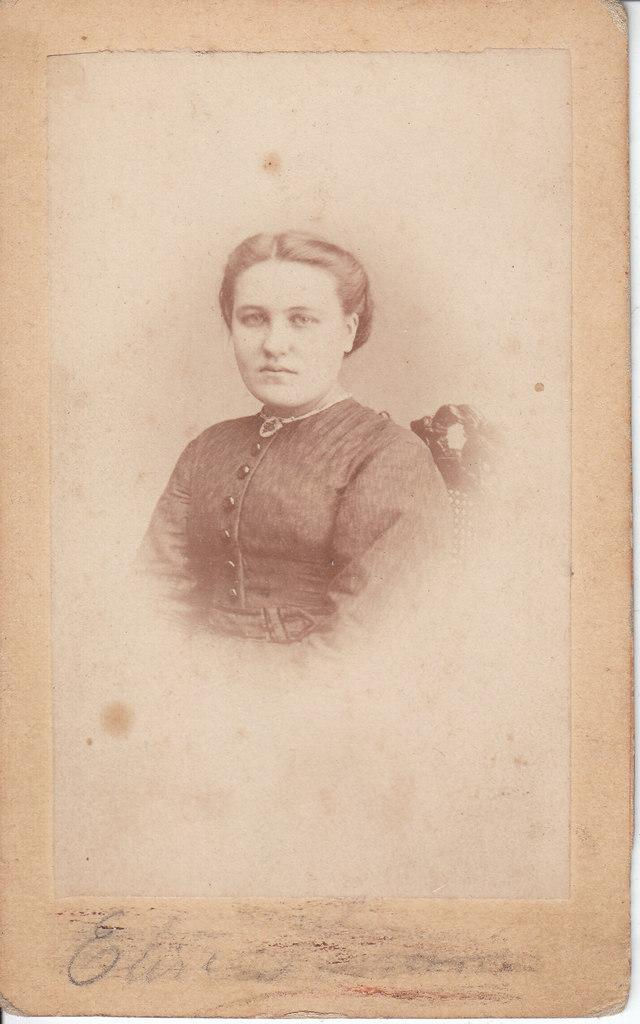What is the main subject of the image? The main subject of the image is a paper. What is depicted in the center of the paper? There is a lady in the center of the image. What type of furniture is present in the image? There is a chair in the image. What can be found at the bottom of the paper? There is some text at the bottom of the image. How many geese are flying over the lady in the image? There are no geese present in the image. What type of pest is causing damage to the paper in the image? There is no pest causing damage to the paper in the image. 